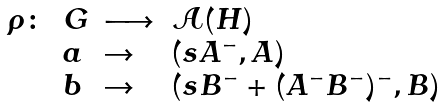Convert formula to latex. <formula><loc_0><loc_0><loc_500><loc_500>\begin{array} { l l l l } \rho \colon & G & \longrightarrow & \mathcal { A } ( H ) \\ & a & \rightarrow & ( s A ^ { - } , A ) \\ & b & \rightarrow & ( s B ^ { - } + ( A ^ { - } B ^ { - } ) ^ { - } , B ) \end{array}</formula> 